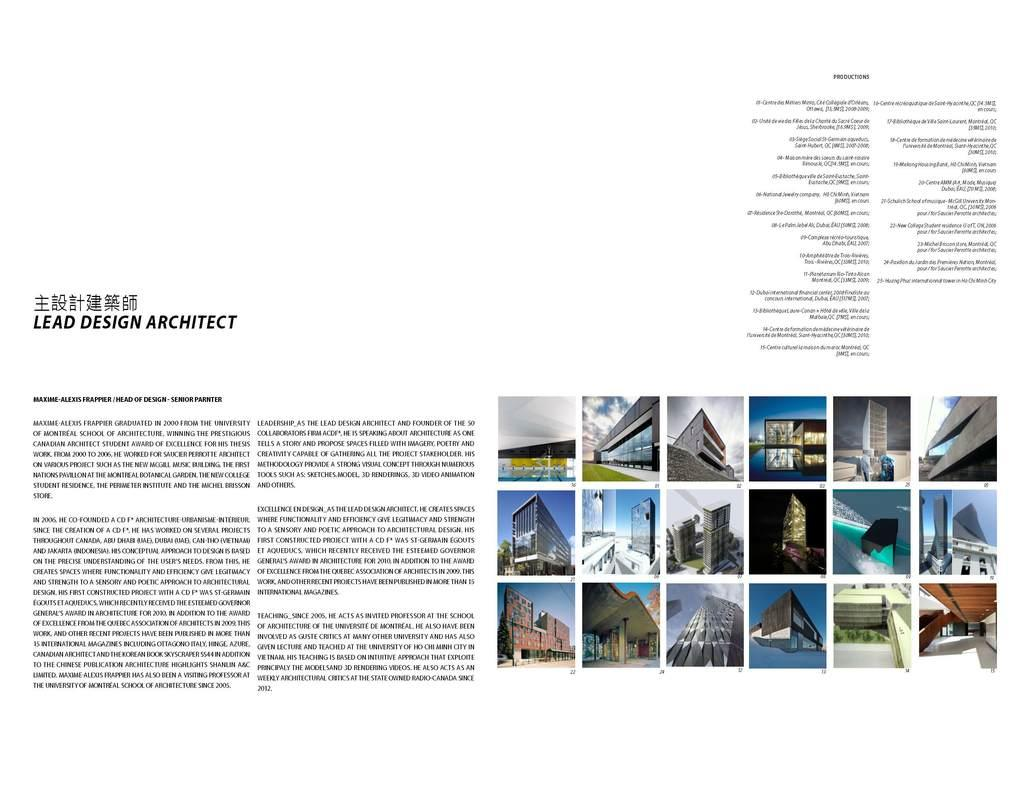What is the main subject of the magazine in the image? The magazine contains information about a lead space architect. What type of content can be found in the magazine? The magazine contains photos of different types of buildings. What type of string can be seen in the image? There is no string present in the image. Can you see a chessboard in the image? There is no chessboard present in the image. 